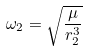<formula> <loc_0><loc_0><loc_500><loc_500>\omega _ { 2 } = \sqrt { \frac { \mu } { r _ { 2 } ^ { 3 } } }</formula> 